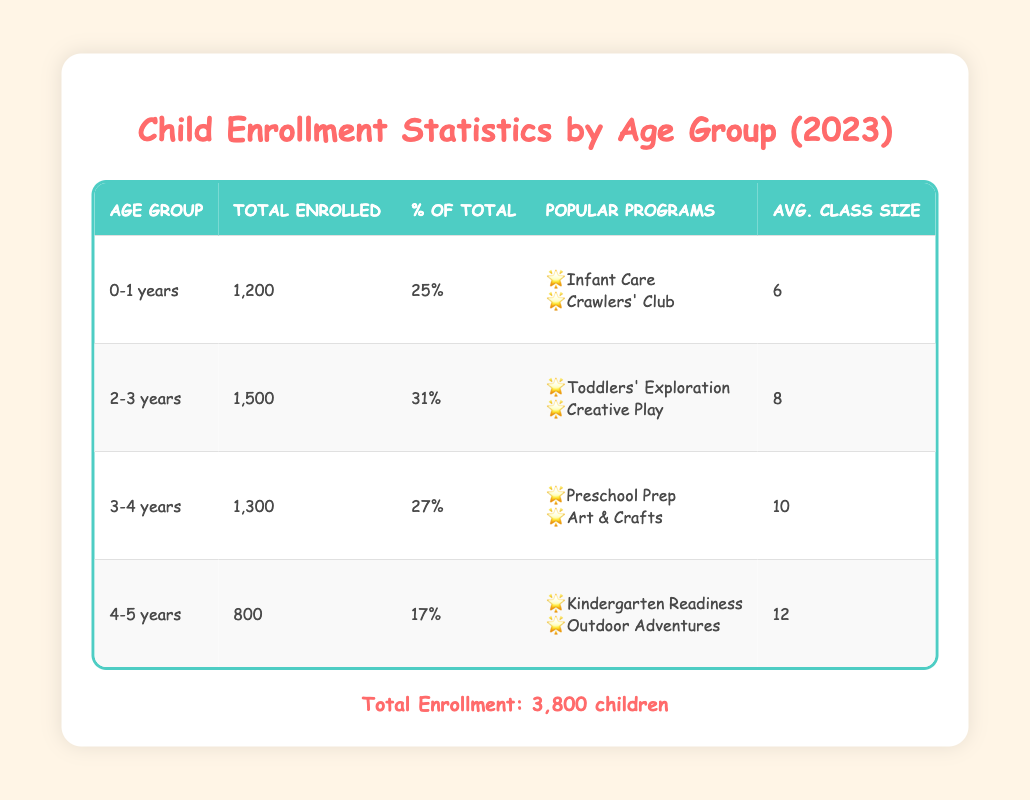What is the total number of children enrolled in 2023? The total enrollment figure for 2023 is provided at the bottom of the table, which states that there are 3,800 children enrolled.
Answer: 3,800 Which age group has the highest number of children enrolled? By comparing the total enrolled numbers for each age group: 0-1 years (1,200), 2-3 years (1,500), 3-4 years (1,300), and 4-5 years (800), the age group with the highest enrollment is 2-3 years with 1,500 children.
Answer: 2-3 years What percentage of the total enrollment is represented by the 4-5 years age group? The percentage of total enrollment for the 4-5 years age group is given in the table as 17%.
Answer: 17% How many children are enrolled in the 0-1 years age group compared to the 3-4 years age group? The 0-1 years age group has 1,200 children enrolled, while the 3-4 years group has 1,300. Calculating the difference: 1,300 - 1,200 = 100, thus 100 more children are enrolled in the 3-4 years age group.
Answer: 100 What is the average class size for the 2-3 years age group? The table directly lists the average class size for the 2-3 years age group, which is 8 children.
Answer: 8 If you combine the total enrollment of the 0-1 years and 4-5 years groups, how many children are enrolled together? The enrollment numbers are 1,200 for the 0-1 years and 800 for the 4-5 years. Adding those together gives: 1,200 + 800 = 2,000.
Answer: 2,000 Is it true that more than half of the total enrollment consists of children aged 2-3 years? The percentage for 2-3 years is 31%, which is less than half (50%). Therefore, it is false that more than half of the enrollment is in this age group.
Answer: No How does the average class size for the 4-5 years age group compare to that of the 0-1 years age group? The average class size for 4-5 years is 12, and for 0-1 years, it is 6. The difference is 12 - 6 = 6, so the 4-5 years group has a larger average class size by 6.
Answer: 6 What is the total number of children enrolled in age groups that have more than 1,000 children? The 2-3 years (1,500) and 0-1 years (1,200) age groups both have more than 1,000. Adding these: 1,500 + 1,200 = 2,700.
Answer: 2,700 Which popular program is listed for the 3-4 years age group? The table specifies that the popular programs for the 3-4 years group include "Preschool Prep" and "Art & Crafts."
Answer: Preschool Prep, Art & Crafts 